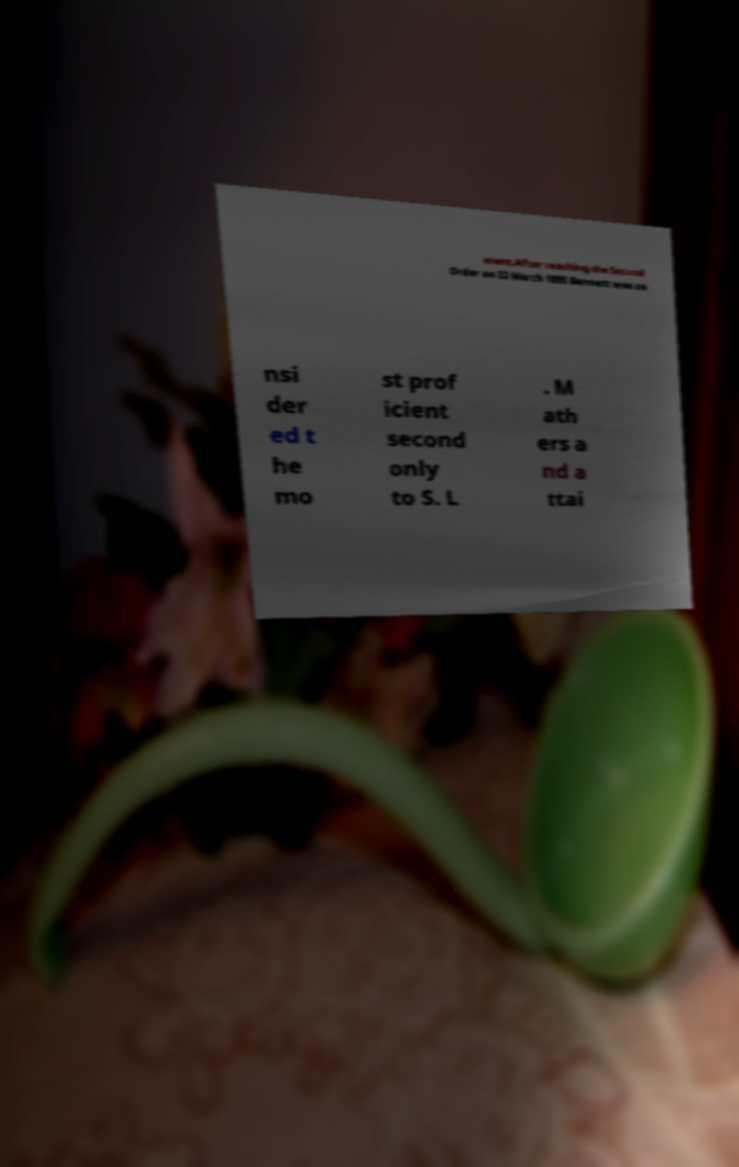What messages or text are displayed in this image? I need them in a readable, typed format. ment.After reaching the Second Order on 22 March 1895 Bennett was co nsi der ed t he mo st prof icient second only to S. L . M ath ers a nd a ttai 